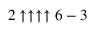Convert formula to latex. <formula><loc_0><loc_0><loc_500><loc_500>2 \uparrow \uparrow \uparrow \uparrow 6 - 3</formula> 